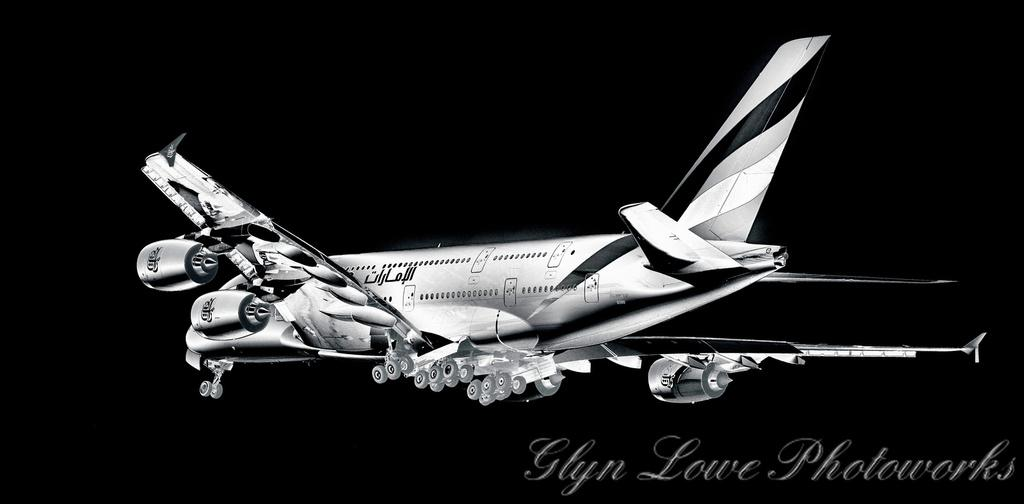What is the main subject of the image? The main subject of the image is an aircraft. Is there any text present in the image? Yes, there is text written on the image. What is the color scheme of the image? The image is in black and white. What is the rhythm of the time displayed on the aircraft in the image? There is no time displayed on the aircraft in the image, and therefore no rhythm can be determined. 